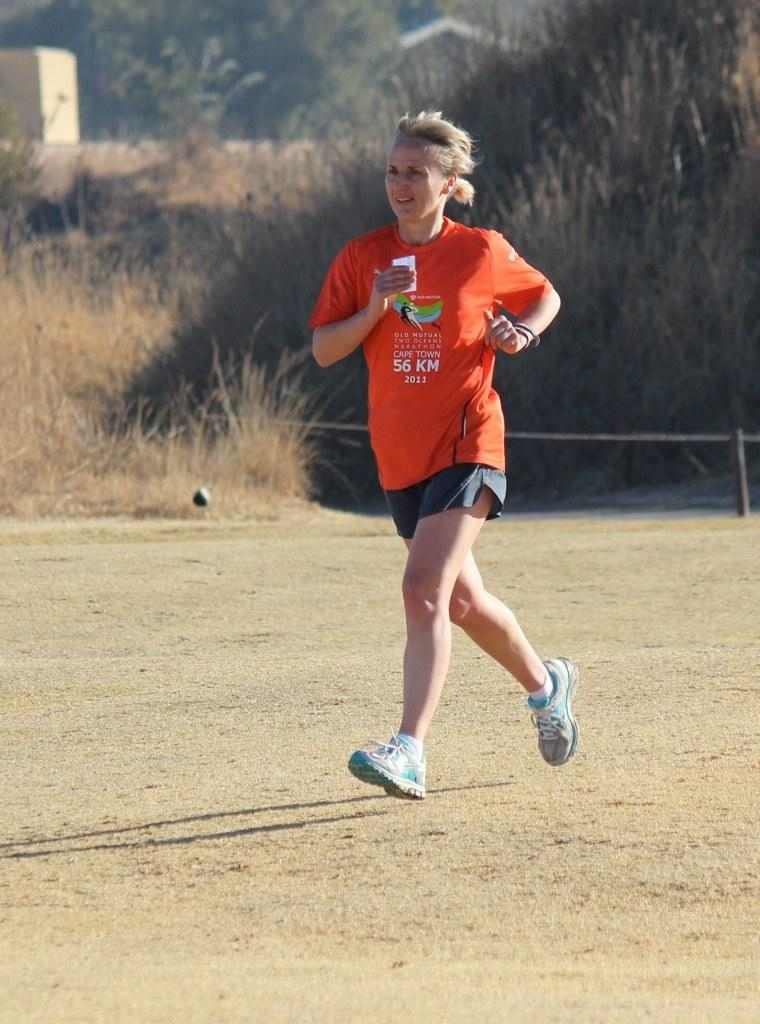Who is the main subject in the image? There is a woman in the image. What is the woman doing in the image? The woman is running on the ground. What is the woman wearing in the image? The woman is wearing an orange T-shirt and a black skirt. What can be seen in the background of the image? There are trees in the background of the image. Can you see a goose flying in the image? There is no goose present in the image. How high can the woman jump while running in the image? The image does not show the woman jumping, only running, so we cannot determine her jumping ability from the image. 